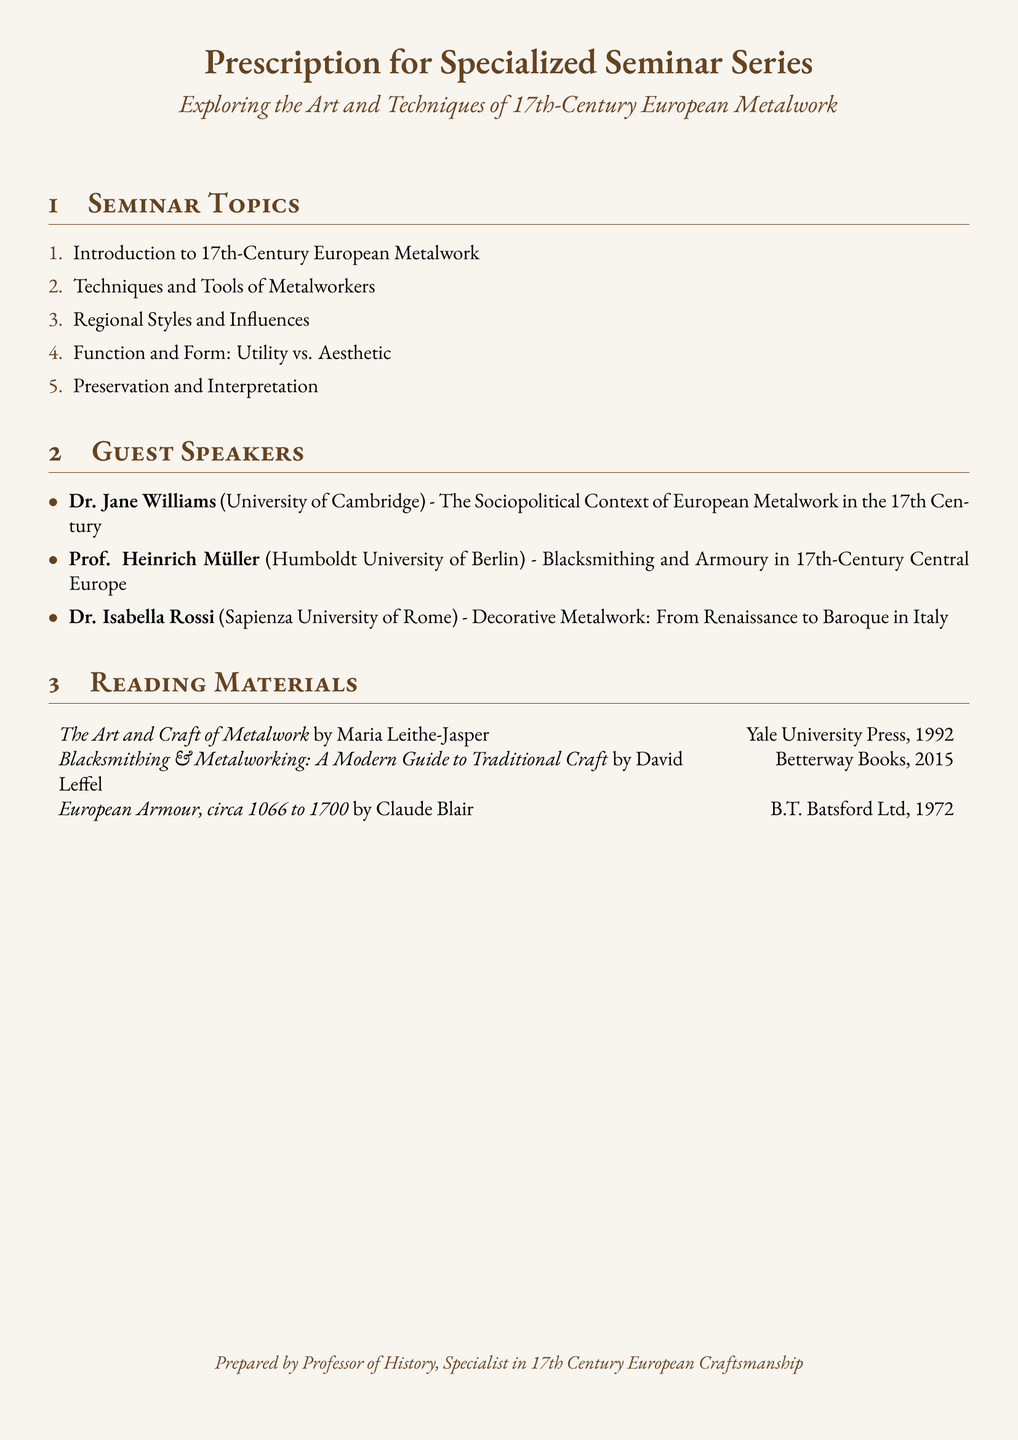What is the title of the seminar series? The title of the seminar series is explicitly stated at the beginning of the document.
Answer: Exploring the Art and Techniques of 17th-Century European Metalwork Who is the guest speaker from the University of Cambridge? The document lists guest speakers with their respective institutions, allowing us to identify the speaker from Cambridge.
Answer: Dr. Jane Williams What is one of the topics covered in the seminar? Topics are listed under the Seminar Topics section, providing specific subjects to be discussed.
Answer: Introduction to 17th-Century European Metalwork Which reading material is authored by Maria Leithe-Jasper? The reading materials section includes the names and titles of books with specific authors.
Answer: The Art and Craft of Metalwork How many guest speakers are listed in the document? The document specifies the number of guest speakers in the Guest Speakers section.
Answer: 3 